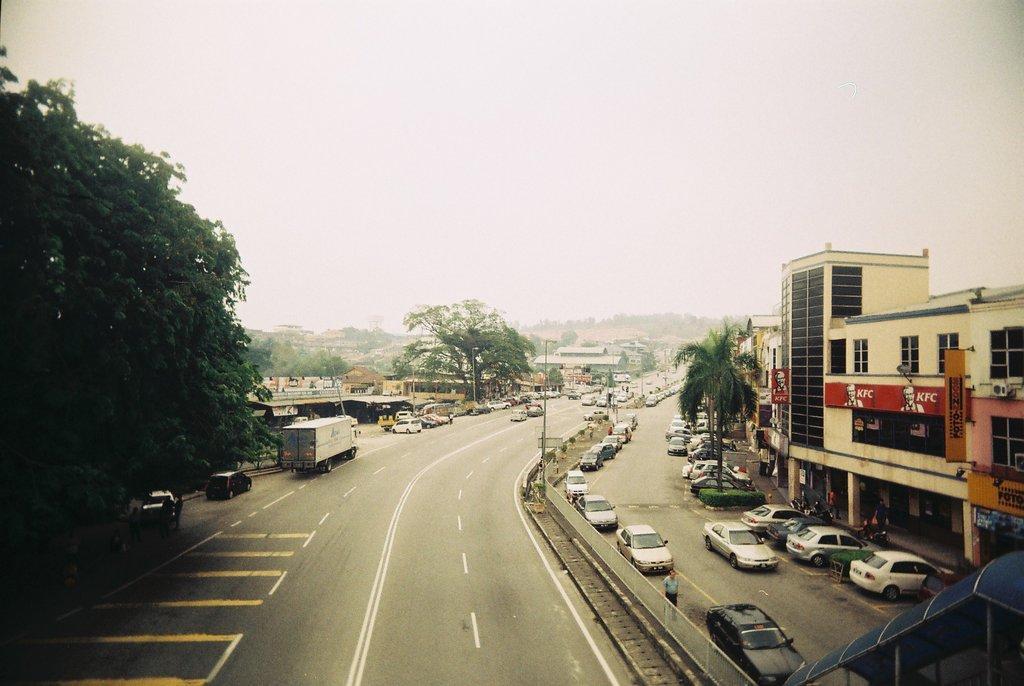How would you summarize this image in a sentence or two? In this picture we can see many cars on the road. Here we can see a man who is standing near to the divider. On the right we can see a truck and other vehicles near to the shed. On the left we can see trees. In the background we can see mountain and shed. On the right there is a building. Here we can see KFC banner. On the top there is a sky. 